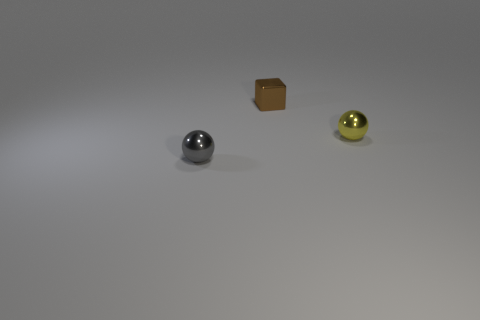There is a yellow ball; is it the same size as the object in front of the yellow ball?
Offer a terse response. Yes. How many gray objects are either small metallic things or small balls?
Your answer should be very brief. 1. What number of gray shiny things are there?
Make the answer very short. 1. There is a sphere that is behind the gray object; what size is it?
Offer a very short reply. Small. Does the block have the same size as the gray object?
Offer a very short reply. Yes. What number of things are gray things or small shiny balls in front of the yellow object?
Make the answer very short. 1. What is the material of the cube?
Offer a very short reply. Metal. Is there anything else that is the same color as the cube?
Offer a very short reply. No. Do the tiny brown thing and the yellow metal thing have the same shape?
Offer a terse response. No. What size is the thing that is in front of the ball that is to the right of the object left of the small brown shiny object?
Your answer should be compact. Small. 